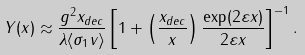<formula> <loc_0><loc_0><loc_500><loc_500>Y ( x ) \approx \frac { g ^ { 2 } x _ { d e c } } { \lambda \langle \sigma _ { 1 } v \rangle } \left [ 1 + \left ( \frac { x _ { d e c } } { x } \right ) \frac { \exp ( 2 \varepsilon x ) } { 2 \varepsilon x } \right ] ^ { - 1 } .</formula> 